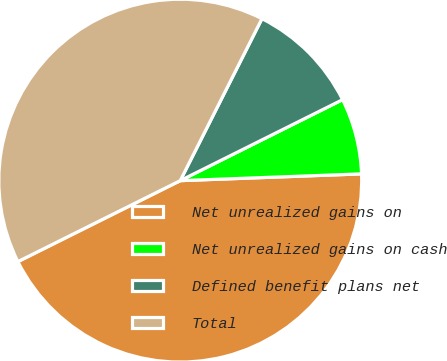<chart> <loc_0><loc_0><loc_500><loc_500><pie_chart><fcel>Net unrealized gains on<fcel>Net unrealized gains on cash<fcel>Defined benefit plans net<fcel>Total<nl><fcel>43.23%<fcel>6.77%<fcel>10.2%<fcel>39.8%<nl></chart> 